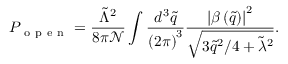<formula> <loc_0><loc_0><loc_500><loc_500>P _ { o p e n } = \frac { \tilde { \Lambda } ^ { 2 } } { 8 \pi \mathcal { N } } \int \frac { d ^ { 3 } \tilde { q } } { \left ( 2 \pi \right ) ^ { 3 } } \frac { \left | \beta \left ( \tilde { q } \right ) \right | ^ { 2 } } { \sqrt { 3 \tilde { q } ^ { 2 } / 4 + \tilde { \lambda } ^ { 2 } } } .</formula> 